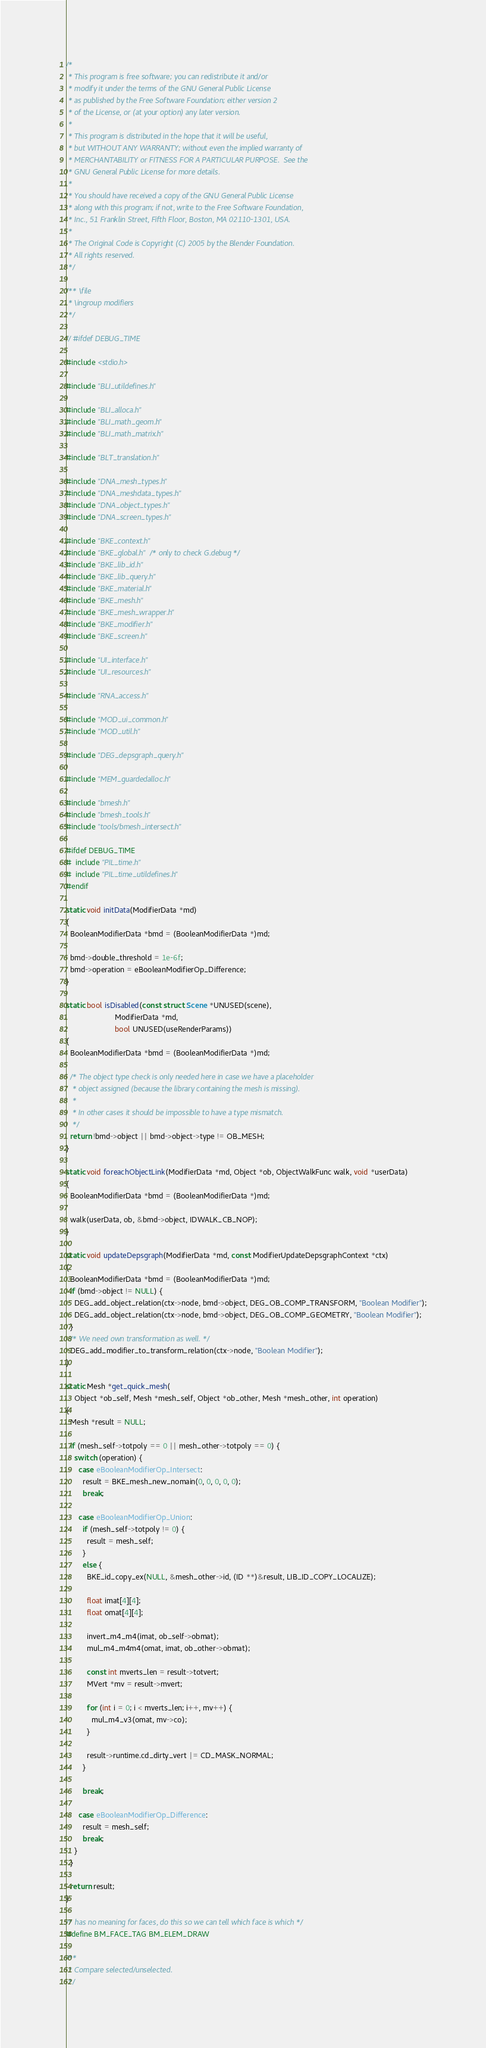Convert code to text. <code><loc_0><loc_0><loc_500><loc_500><_C_>/*
 * This program is free software; you can redistribute it and/or
 * modify it under the terms of the GNU General Public License
 * as published by the Free Software Foundation; either version 2
 * of the License, or (at your option) any later version.
 *
 * This program is distributed in the hope that it will be useful,
 * but WITHOUT ANY WARRANTY; without even the implied warranty of
 * MERCHANTABILITY or FITNESS FOR A PARTICULAR PURPOSE.  See the
 * GNU General Public License for more details.
 *
 * You should have received a copy of the GNU General Public License
 * along with this program; if not, write to the Free Software Foundation,
 * Inc., 51 Franklin Street, Fifth Floor, Boston, MA 02110-1301, USA.
 *
 * The Original Code is Copyright (C) 2005 by the Blender Foundation.
 * All rights reserved.
 */

/** \file
 * \ingroup modifiers
 */

// #ifdef DEBUG_TIME

#include <stdio.h>

#include "BLI_utildefines.h"

#include "BLI_alloca.h"
#include "BLI_math_geom.h"
#include "BLI_math_matrix.h"

#include "BLT_translation.h"

#include "DNA_mesh_types.h"
#include "DNA_meshdata_types.h"
#include "DNA_object_types.h"
#include "DNA_screen_types.h"

#include "BKE_context.h"
#include "BKE_global.h" /* only to check G.debug */
#include "BKE_lib_id.h"
#include "BKE_lib_query.h"
#include "BKE_material.h"
#include "BKE_mesh.h"
#include "BKE_mesh_wrapper.h"
#include "BKE_modifier.h"
#include "BKE_screen.h"

#include "UI_interface.h"
#include "UI_resources.h"

#include "RNA_access.h"

#include "MOD_ui_common.h"
#include "MOD_util.h"

#include "DEG_depsgraph_query.h"

#include "MEM_guardedalloc.h"

#include "bmesh.h"
#include "bmesh_tools.h"
#include "tools/bmesh_intersect.h"

#ifdef DEBUG_TIME
#  include "PIL_time.h"
#  include "PIL_time_utildefines.h"
#endif

static void initData(ModifierData *md)
{
  BooleanModifierData *bmd = (BooleanModifierData *)md;

  bmd->double_threshold = 1e-6f;
  bmd->operation = eBooleanModifierOp_Difference;
}

static bool isDisabled(const struct Scene *UNUSED(scene),
                       ModifierData *md,
                       bool UNUSED(useRenderParams))
{
  BooleanModifierData *bmd = (BooleanModifierData *)md;

  /* The object type check is only needed here in case we have a placeholder
   * object assigned (because the library containing the mesh is missing).
   *
   * In other cases it should be impossible to have a type mismatch.
   */
  return !bmd->object || bmd->object->type != OB_MESH;
}

static void foreachObjectLink(ModifierData *md, Object *ob, ObjectWalkFunc walk, void *userData)
{
  BooleanModifierData *bmd = (BooleanModifierData *)md;

  walk(userData, ob, &bmd->object, IDWALK_CB_NOP);
}

static void updateDepsgraph(ModifierData *md, const ModifierUpdateDepsgraphContext *ctx)
{
  BooleanModifierData *bmd = (BooleanModifierData *)md;
  if (bmd->object != NULL) {
    DEG_add_object_relation(ctx->node, bmd->object, DEG_OB_COMP_TRANSFORM, "Boolean Modifier");
    DEG_add_object_relation(ctx->node, bmd->object, DEG_OB_COMP_GEOMETRY, "Boolean Modifier");
  }
  /* We need own transformation as well. */
  DEG_add_modifier_to_transform_relation(ctx->node, "Boolean Modifier");
}

static Mesh *get_quick_mesh(
    Object *ob_self, Mesh *mesh_self, Object *ob_other, Mesh *mesh_other, int operation)
{
  Mesh *result = NULL;

  if (mesh_self->totpoly == 0 || mesh_other->totpoly == 0) {
    switch (operation) {
      case eBooleanModifierOp_Intersect:
        result = BKE_mesh_new_nomain(0, 0, 0, 0, 0);
        break;

      case eBooleanModifierOp_Union:
        if (mesh_self->totpoly != 0) {
          result = mesh_self;
        }
        else {
          BKE_id_copy_ex(NULL, &mesh_other->id, (ID **)&result, LIB_ID_COPY_LOCALIZE);

          float imat[4][4];
          float omat[4][4];

          invert_m4_m4(imat, ob_self->obmat);
          mul_m4_m4m4(omat, imat, ob_other->obmat);

          const int mverts_len = result->totvert;
          MVert *mv = result->mvert;

          for (int i = 0; i < mverts_len; i++, mv++) {
            mul_m4_v3(omat, mv->co);
          }

          result->runtime.cd_dirty_vert |= CD_MASK_NORMAL;
        }

        break;

      case eBooleanModifierOp_Difference:
        result = mesh_self;
        break;
    }
  }

  return result;
}

/* has no meaning for faces, do this so we can tell which face is which */
#define BM_FACE_TAG BM_ELEM_DRAW

/**
 * Compare selected/unselected.
 */</code> 